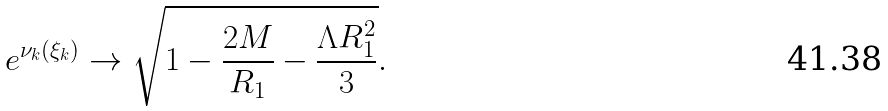<formula> <loc_0><loc_0><loc_500><loc_500>e ^ { \nu _ { k } ( \xi _ { k } ) } \to \sqrt { 1 - \frac { 2 M } { R _ { 1 } } - \frac { \Lambda R ^ { 2 } _ { 1 } } { 3 } } .</formula> 